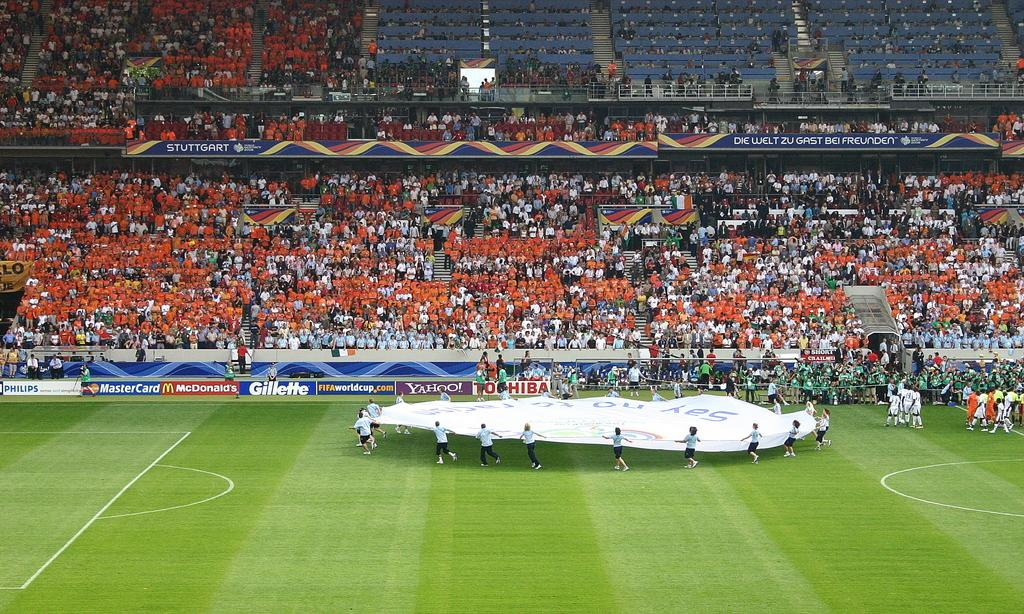Provide a one-sentence caption for the provided image. Several people hold a large round piece of cloth in front of ads for Gillette and Toshiba. 